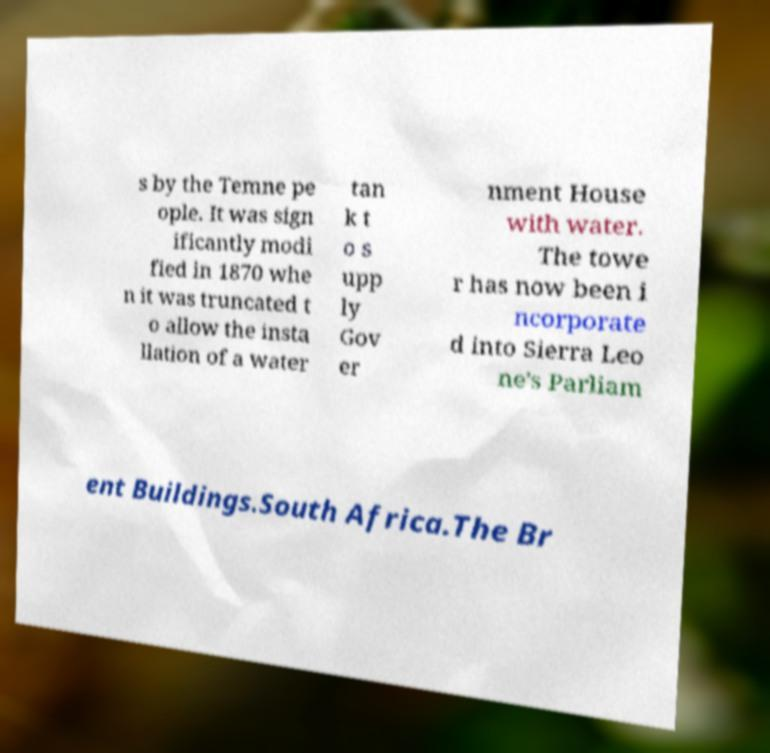There's text embedded in this image that I need extracted. Can you transcribe it verbatim? s by the Temne pe ople. It was sign ificantly modi fied in 1870 whe n it was truncated t o allow the insta llation of a water tan k t o s upp ly Gov er nment House with water. The towe r has now been i ncorporate d into Sierra Leo ne's Parliam ent Buildings.South Africa.The Br 